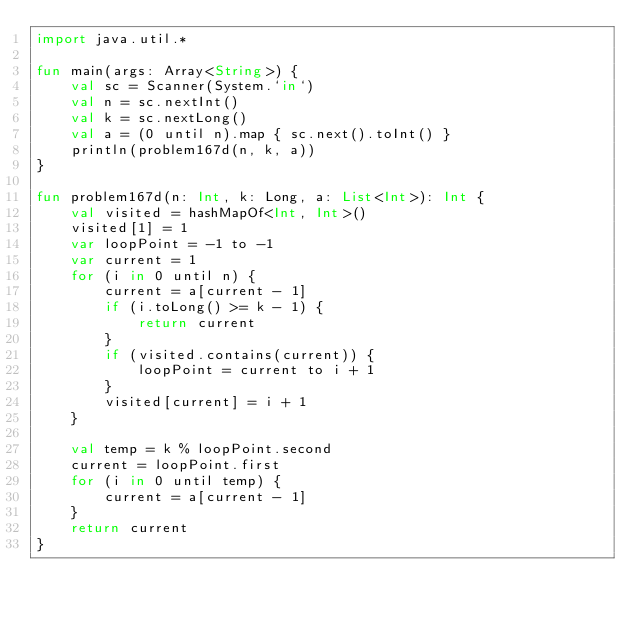<code> <loc_0><loc_0><loc_500><loc_500><_Kotlin_>import java.util.*

fun main(args: Array<String>) {
    val sc = Scanner(System.`in`)
    val n = sc.nextInt()
    val k = sc.nextLong()
    val a = (0 until n).map { sc.next().toInt() }
    println(problem167d(n, k, a))
}

fun problem167d(n: Int, k: Long, a: List<Int>): Int {
    val visited = hashMapOf<Int, Int>()
    visited[1] = 1
    var loopPoint = -1 to -1
    var current = 1
    for (i in 0 until n) {
        current = a[current - 1]
        if (i.toLong() >= k - 1) {
            return current
        }
        if (visited.contains(current)) {
            loopPoint = current to i + 1
        }
        visited[current] = i + 1
    }

    val temp = k % loopPoint.second
    current = loopPoint.first
    for (i in 0 until temp) {
        current = a[current - 1]
    }
    return current
}</code> 